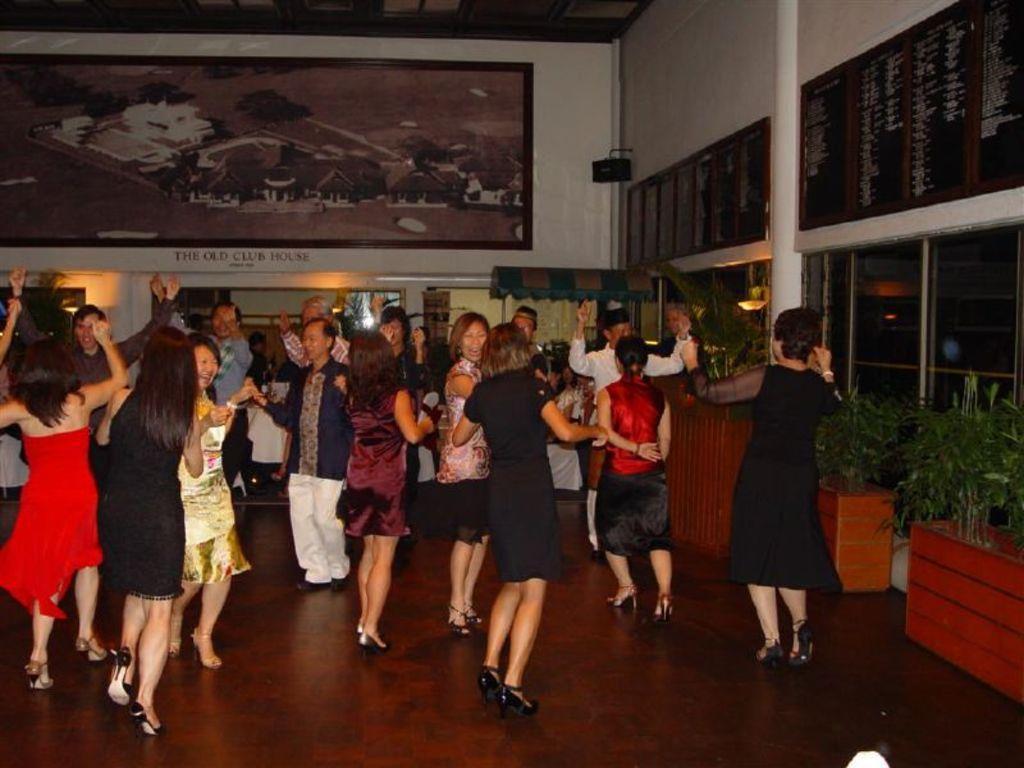Describe this image in one or two sentences. In this image few persons are dancing on the floor. Right side of the image there are few pots having plants in it. Behind the persons there is a stall. A frame is attached to the wall. A lamp is attached to the wall having windows. 